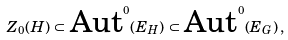Convert formula to latex. <formula><loc_0><loc_0><loc_500><loc_500>Z _ { 0 } ( H ) \, \subset \, \text {Aut} ^ { 0 } ( E _ { H } ) \, \subset \, \text {Aut} ^ { 0 } ( E _ { G } ) \, ,</formula> 